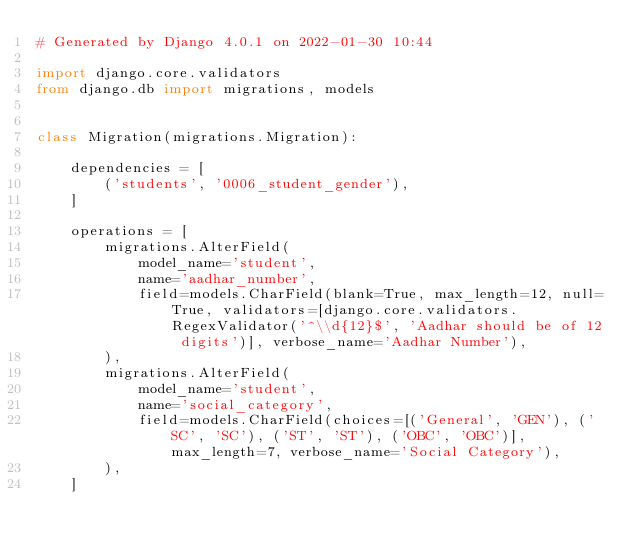Convert code to text. <code><loc_0><loc_0><loc_500><loc_500><_Python_># Generated by Django 4.0.1 on 2022-01-30 10:44

import django.core.validators
from django.db import migrations, models


class Migration(migrations.Migration):

    dependencies = [
        ('students', '0006_student_gender'),
    ]

    operations = [
        migrations.AlterField(
            model_name='student',
            name='aadhar_number',
            field=models.CharField(blank=True, max_length=12, null=True, validators=[django.core.validators.RegexValidator('^\\d{12}$', 'Aadhar should be of 12 digits')], verbose_name='Aadhar Number'),
        ),
        migrations.AlterField(
            model_name='student',
            name='social_category',
            field=models.CharField(choices=[('General', 'GEN'), ('SC', 'SC'), ('ST', 'ST'), ('OBC', 'OBC')], max_length=7, verbose_name='Social Category'),
        ),
    ]
</code> 